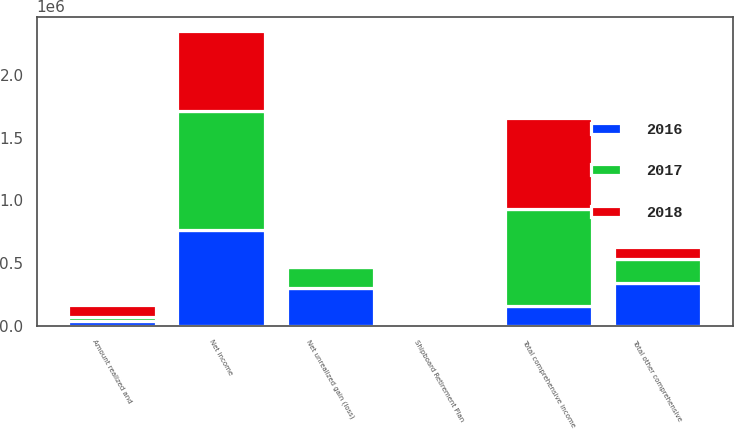Convert chart. <chart><loc_0><loc_0><loc_500><loc_500><stacked_bar_chart><ecel><fcel>Net income<fcel>Shipboard Retirement Plan<fcel>Net unrealized gain (loss)<fcel>Amount realized and<fcel>Total other comprehensive<fcel>Total comprehensive income<nl><fcel>2017<fcel>954843<fcel>2697<fcel>161214<fcel>30096<fcel>188613<fcel>766230<nl><fcel>2016<fcel>759872<fcel>40<fcel>304684<fcel>36795<fcel>341439<fcel>161214<nl><fcel>2018<fcel>633085<fcel>497<fcel>1711<fcel>95969<fcel>98177<fcel>731262<nl></chart> 